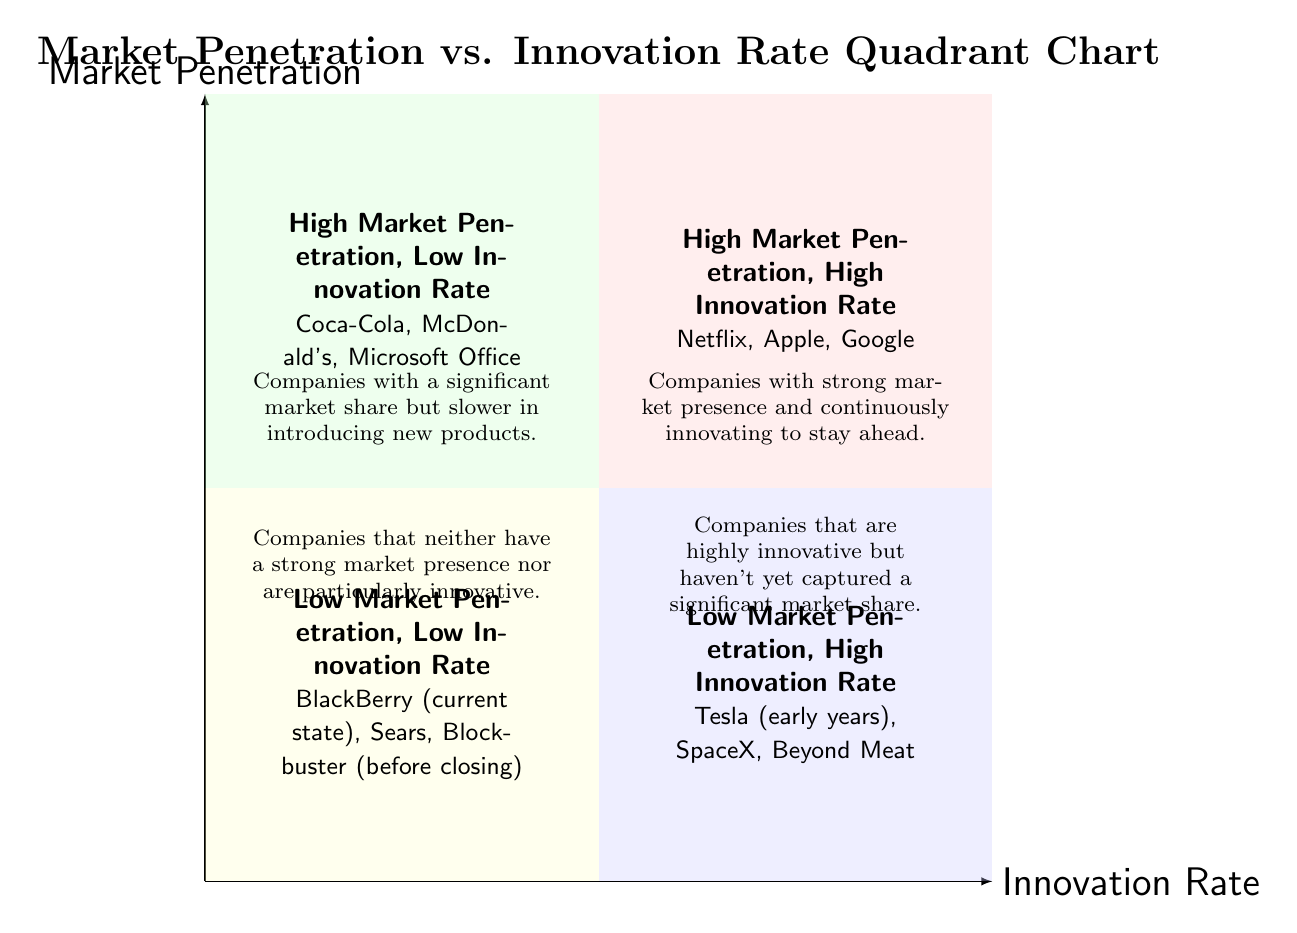What companies are in the "High Market Penetration, High Innovation Rate" quadrant? The question asks for specific examples of companies located in the quadrant designated as "High Market Penetration, High Innovation Rate." The diagram states that this quadrant includes Netflix, Apple, and Google.
Answer: Netflix, Apple, Google What is the description of the "Low Market Penetration, Low Innovation Rate" quadrant? This question is asking for the explanatory text under the quadrant labeled "Low Market Penetration, Low Innovation Rate." Referring to the diagram, it describes companies that neither have a strong market presence nor are particularly innovative.
Answer: Companies that neither have a strong market presence nor are particularly innovative Which quadrant contains Coca-Cola? This requires identifying the quadrant where Coca-Cola is located, based on the information given in the diagram. Coca-Cola is listed under the "High Market Penetration, Low Innovation Rate" quadrant.
Answer: High Market Penetration, Low Innovation Rate How many quadrants are described in the chart? This is a straightforward question asking for the count of the quadrants depicted in the diagram. There are four distinct quadrants described, each with different characteristics.
Answer: Four Which sector does Tesla (in its early years) belong to? This question retrieves specific placement regarding Tesla's position in the quadrant chart. The diagram indicates that Tesla, in its early years, fits in the "Low Market Penetration, High Innovation Rate" quadrant.
Answer: Low Market Penetration, High Innovation Rate What is the contrast between companies in the "High Market Penetration, Low Innovation Rate" and "Low Market Penetration, High Innovation Rate" quadrants? To answer this question, one must analyze the descriptions of both quadrants. The first quadrant consists of companies with significant market share but slower innovation, while the second quadrant is for companies that are innovative but haven't gained much market share.
Answer: Significant market share vs. High innovation How can a company improve its position from "Low Market Penetration, Low Innovation Rate" to "High Market Penetration, High Innovation Rate"? This question requires a deeper reasoning about the moves a company could make to climb the quadrant levels. A company would need to innovate consistently and also enhance its market presence through effective strategies like marketing, quality improvements, or expansion efforts.
Answer: Innovate consistently and enhance market presence 